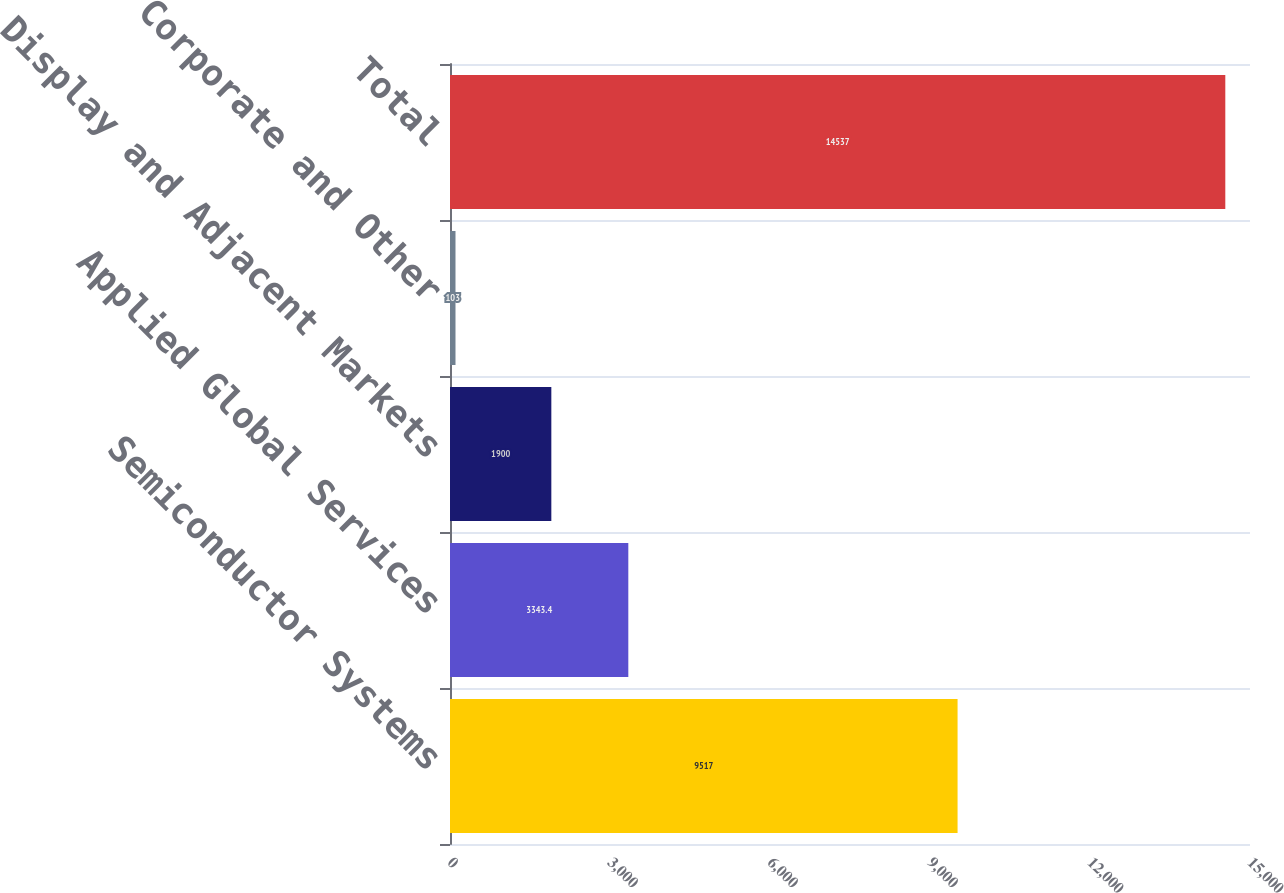Convert chart to OTSL. <chart><loc_0><loc_0><loc_500><loc_500><bar_chart><fcel>Semiconductor Systems<fcel>Applied Global Services<fcel>Display and Adjacent Markets<fcel>Corporate and Other<fcel>Total<nl><fcel>9517<fcel>3343.4<fcel>1900<fcel>103<fcel>14537<nl></chart> 